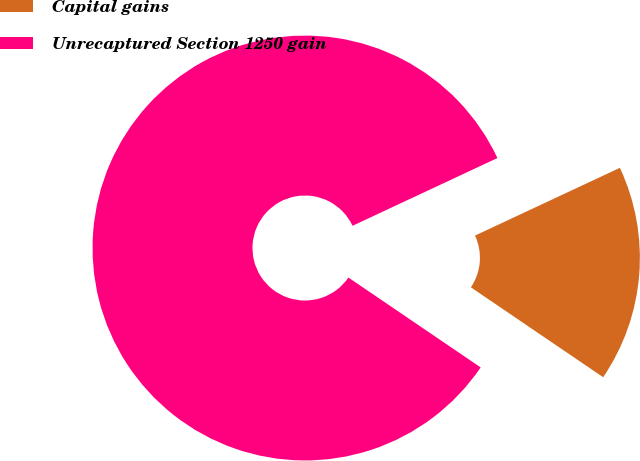Convert chart. <chart><loc_0><loc_0><loc_500><loc_500><pie_chart><fcel>Capital gains<fcel>Unrecaptured Section 1250 gain<nl><fcel>16.46%<fcel>83.54%<nl></chart> 